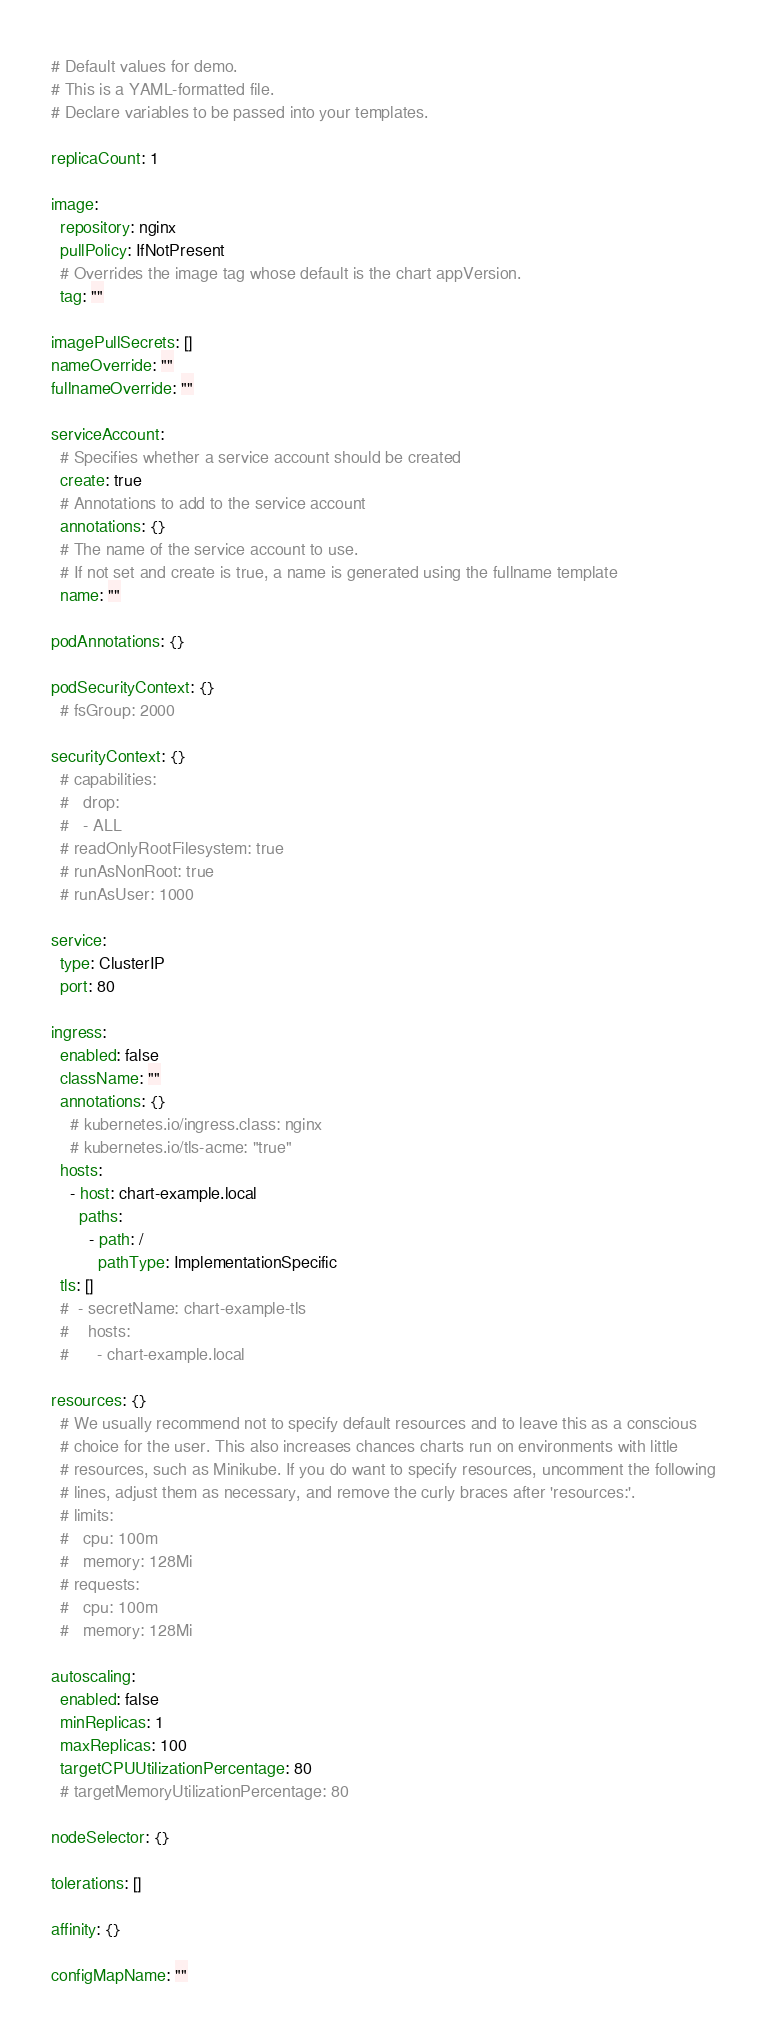<code> <loc_0><loc_0><loc_500><loc_500><_YAML_># Default values for demo.
# This is a YAML-formatted file.
# Declare variables to be passed into your templates.

replicaCount: 1

image:
  repository: nginx
  pullPolicy: IfNotPresent
  # Overrides the image tag whose default is the chart appVersion.
  tag: ""

imagePullSecrets: []
nameOverride: ""
fullnameOverride: ""

serviceAccount:
  # Specifies whether a service account should be created
  create: true
  # Annotations to add to the service account
  annotations: {}
  # The name of the service account to use.
  # If not set and create is true, a name is generated using the fullname template
  name: ""

podAnnotations: {}

podSecurityContext: {}
  # fsGroup: 2000

securityContext: {}
  # capabilities:
  #   drop:
  #   - ALL
  # readOnlyRootFilesystem: true
  # runAsNonRoot: true
  # runAsUser: 1000

service:
  type: ClusterIP
  port: 80

ingress:
  enabled: false
  className: ""
  annotations: {}
    # kubernetes.io/ingress.class: nginx
    # kubernetes.io/tls-acme: "true"
  hosts:
    - host: chart-example.local
      paths:
        - path: /
          pathType: ImplementationSpecific
  tls: []
  #  - secretName: chart-example-tls
  #    hosts:
  #      - chart-example.local

resources: {}
  # We usually recommend not to specify default resources and to leave this as a conscious
  # choice for the user. This also increases chances charts run on environments with little
  # resources, such as Minikube. If you do want to specify resources, uncomment the following
  # lines, adjust them as necessary, and remove the curly braces after 'resources:'.
  # limits:
  #   cpu: 100m
  #   memory: 128Mi
  # requests:
  #   cpu: 100m
  #   memory: 128Mi

autoscaling:
  enabled: false
  minReplicas: 1
  maxReplicas: 100
  targetCPUUtilizationPercentage: 80
  # targetMemoryUtilizationPercentage: 80

nodeSelector: {}

tolerations: []

affinity: {}

configMapName: ""
</code> 